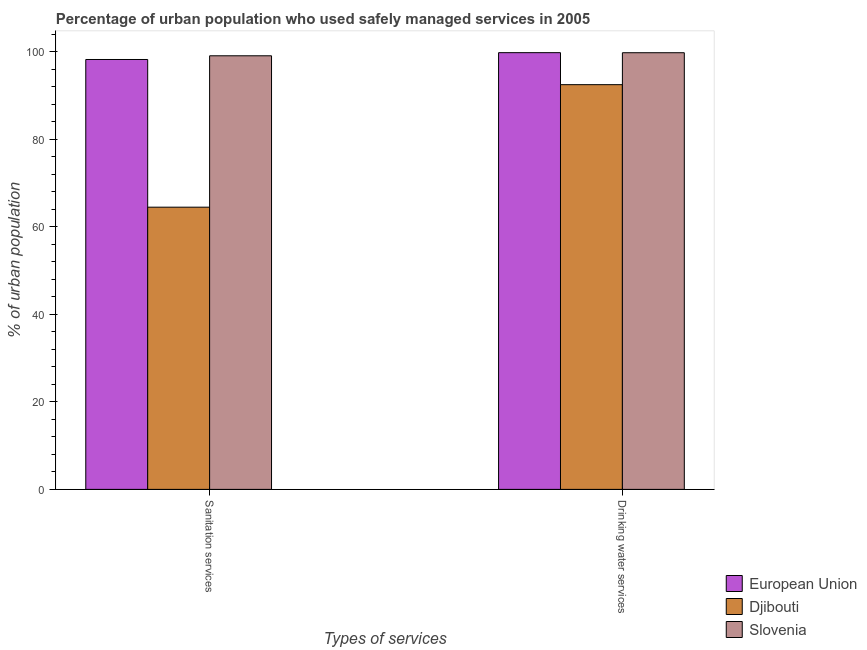How many groups of bars are there?
Offer a terse response. 2. Are the number of bars per tick equal to the number of legend labels?
Give a very brief answer. Yes. Are the number of bars on each tick of the X-axis equal?
Offer a very short reply. Yes. How many bars are there on the 1st tick from the left?
Provide a succinct answer. 3. How many bars are there on the 1st tick from the right?
Provide a succinct answer. 3. What is the label of the 2nd group of bars from the left?
Your answer should be very brief. Drinking water services. What is the percentage of urban population who used sanitation services in European Union?
Your response must be concise. 98.25. Across all countries, what is the maximum percentage of urban population who used drinking water services?
Offer a very short reply. 99.81. Across all countries, what is the minimum percentage of urban population who used sanitation services?
Make the answer very short. 64.5. In which country was the percentage of urban population who used sanitation services maximum?
Offer a terse response. Slovenia. In which country was the percentage of urban population who used drinking water services minimum?
Your response must be concise. Djibouti. What is the total percentage of urban population who used sanitation services in the graph?
Offer a very short reply. 261.85. What is the difference between the percentage of urban population who used sanitation services in Djibouti and that in Slovenia?
Ensure brevity in your answer.  -34.6. What is the difference between the percentage of urban population who used sanitation services in Djibouti and the percentage of urban population who used drinking water services in Slovenia?
Offer a terse response. -35.3. What is the average percentage of urban population who used sanitation services per country?
Offer a very short reply. 87.28. What is the difference between the percentage of urban population who used sanitation services and percentage of urban population who used drinking water services in Slovenia?
Your response must be concise. -0.7. What is the ratio of the percentage of urban population who used sanitation services in European Union to that in Djibouti?
Your answer should be very brief. 1.52. What does the 1st bar from the left in Drinking water services represents?
Provide a short and direct response. European Union. How many bars are there?
Provide a short and direct response. 6. Are all the bars in the graph horizontal?
Ensure brevity in your answer.  No. What is the difference between two consecutive major ticks on the Y-axis?
Ensure brevity in your answer.  20. Are the values on the major ticks of Y-axis written in scientific E-notation?
Your answer should be very brief. No. Does the graph contain grids?
Keep it short and to the point. No. Where does the legend appear in the graph?
Provide a short and direct response. Bottom right. What is the title of the graph?
Your answer should be very brief. Percentage of urban population who used safely managed services in 2005. Does "Romania" appear as one of the legend labels in the graph?
Keep it short and to the point. No. What is the label or title of the X-axis?
Provide a short and direct response. Types of services. What is the label or title of the Y-axis?
Your answer should be compact. % of urban population. What is the % of urban population of European Union in Sanitation services?
Your answer should be compact. 98.25. What is the % of urban population in Djibouti in Sanitation services?
Make the answer very short. 64.5. What is the % of urban population in Slovenia in Sanitation services?
Provide a short and direct response. 99.1. What is the % of urban population of European Union in Drinking water services?
Keep it short and to the point. 99.81. What is the % of urban population of Djibouti in Drinking water services?
Your answer should be compact. 92.5. What is the % of urban population of Slovenia in Drinking water services?
Provide a succinct answer. 99.8. Across all Types of services, what is the maximum % of urban population of European Union?
Ensure brevity in your answer.  99.81. Across all Types of services, what is the maximum % of urban population of Djibouti?
Your answer should be very brief. 92.5. Across all Types of services, what is the maximum % of urban population of Slovenia?
Offer a very short reply. 99.8. Across all Types of services, what is the minimum % of urban population of European Union?
Ensure brevity in your answer.  98.25. Across all Types of services, what is the minimum % of urban population of Djibouti?
Your response must be concise. 64.5. Across all Types of services, what is the minimum % of urban population in Slovenia?
Your answer should be very brief. 99.1. What is the total % of urban population in European Union in the graph?
Offer a very short reply. 198.07. What is the total % of urban population of Djibouti in the graph?
Your response must be concise. 157. What is the total % of urban population of Slovenia in the graph?
Give a very brief answer. 198.9. What is the difference between the % of urban population of European Union in Sanitation services and that in Drinking water services?
Provide a succinct answer. -1.56. What is the difference between the % of urban population of Slovenia in Sanitation services and that in Drinking water services?
Provide a short and direct response. -0.7. What is the difference between the % of urban population of European Union in Sanitation services and the % of urban population of Djibouti in Drinking water services?
Provide a succinct answer. 5.75. What is the difference between the % of urban population in European Union in Sanitation services and the % of urban population in Slovenia in Drinking water services?
Your answer should be very brief. -1.55. What is the difference between the % of urban population in Djibouti in Sanitation services and the % of urban population in Slovenia in Drinking water services?
Offer a terse response. -35.3. What is the average % of urban population of European Union per Types of services?
Your answer should be compact. 99.03. What is the average % of urban population in Djibouti per Types of services?
Your answer should be compact. 78.5. What is the average % of urban population of Slovenia per Types of services?
Offer a very short reply. 99.45. What is the difference between the % of urban population in European Union and % of urban population in Djibouti in Sanitation services?
Give a very brief answer. 33.75. What is the difference between the % of urban population in European Union and % of urban population in Slovenia in Sanitation services?
Your answer should be compact. -0.85. What is the difference between the % of urban population in Djibouti and % of urban population in Slovenia in Sanitation services?
Keep it short and to the point. -34.6. What is the difference between the % of urban population in European Union and % of urban population in Djibouti in Drinking water services?
Ensure brevity in your answer.  7.31. What is the difference between the % of urban population in European Union and % of urban population in Slovenia in Drinking water services?
Your response must be concise. 0.01. What is the difference between the % of urban population of Djibouti and % of urban population of Slovenia in Drinking water services?
Provide a short and direct response. -7.3. What is the ratio of the % of urban population in European Union in Sanitation services to that in Drinking water services?
Keep it short and to the point. 0.98. What is the ratio of the % of urban population of Djibouti in Sanitation services to that in Drinking water services?
Your answer should be very brief. 0.7. What is the difference between the highest and the second highest % of urban population in European Union?
Your answer should be very brief. 1.56. What is the difference between the highest and the second highest % of urban population of Slovenia?
Make the answer very short. 0.7. What is the difference between the highest and the lowest % of urban population of European Union?
Your response must be concise. 1.56. What is the difference between the highest and the lowest % of urban population of Slovenia?
Offer a terse response. 0.7. 